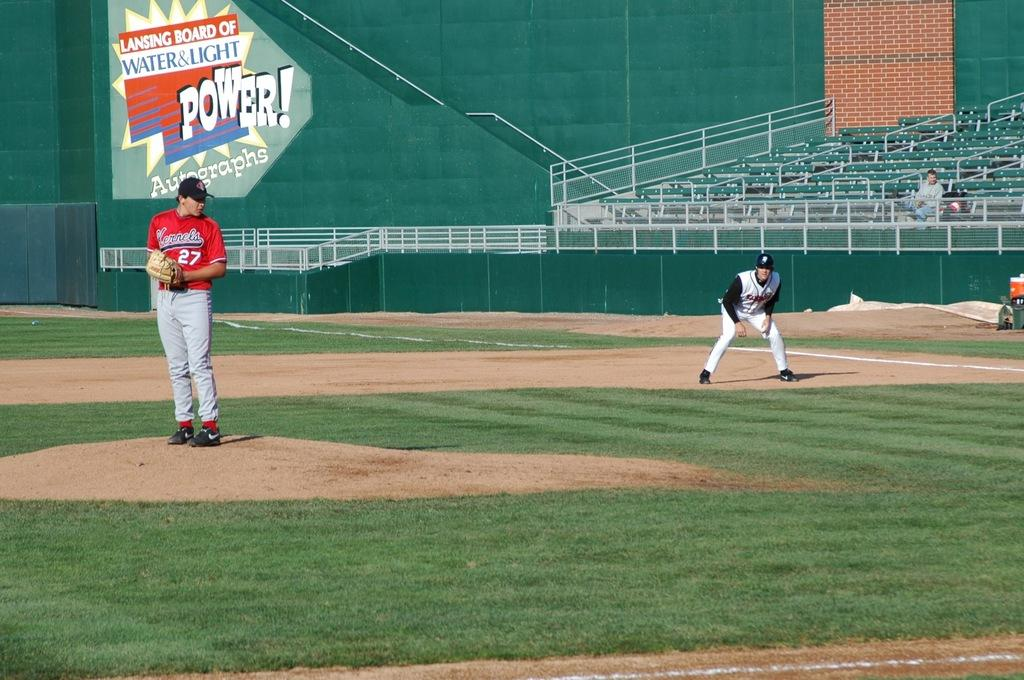<image>
Summarize the visual content of the image. a pitcher with the number 27 getting ready to throw 